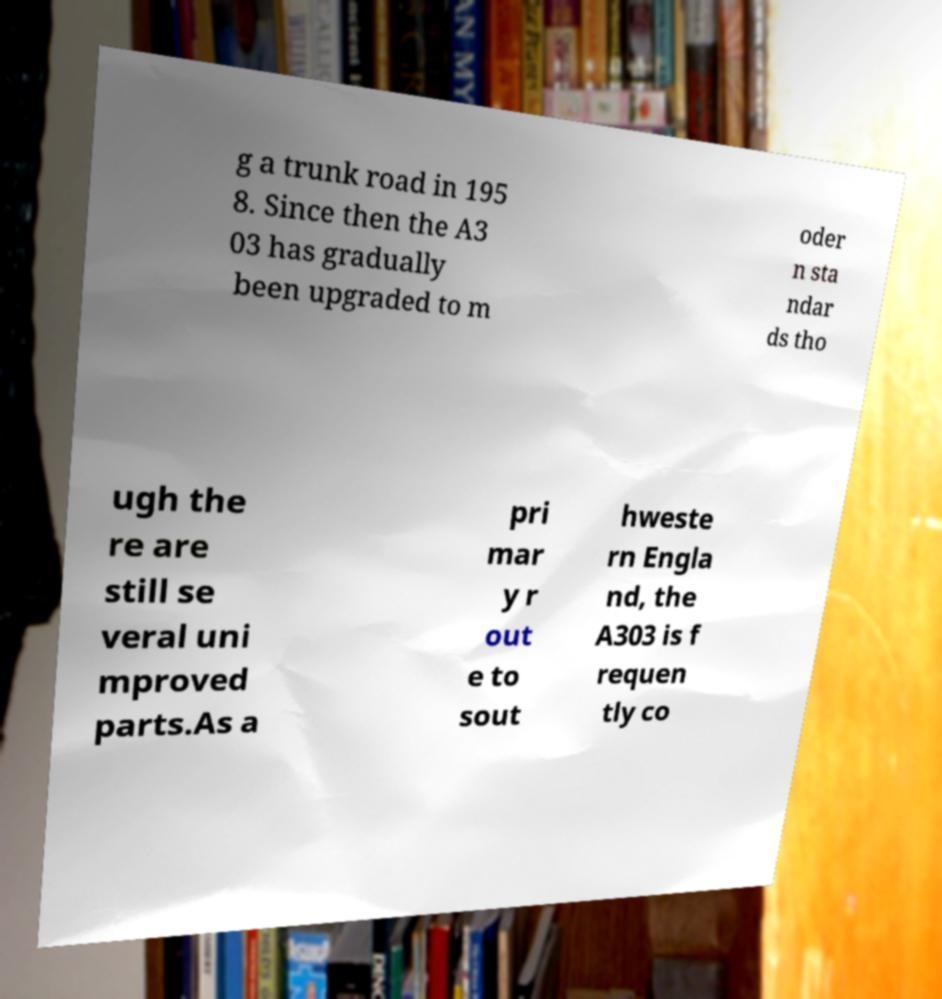Please read and relay the text visible in this image. What does it say? g a trunk road in 195 8. Since then the A3 03 has gradually been upgraded to m oder n sta ndar ds tho ugh the re are still se veral uni mproved parts.As a pri mar y r out e to sout hweste rn Engla nd, the A303 is f requen tly co 